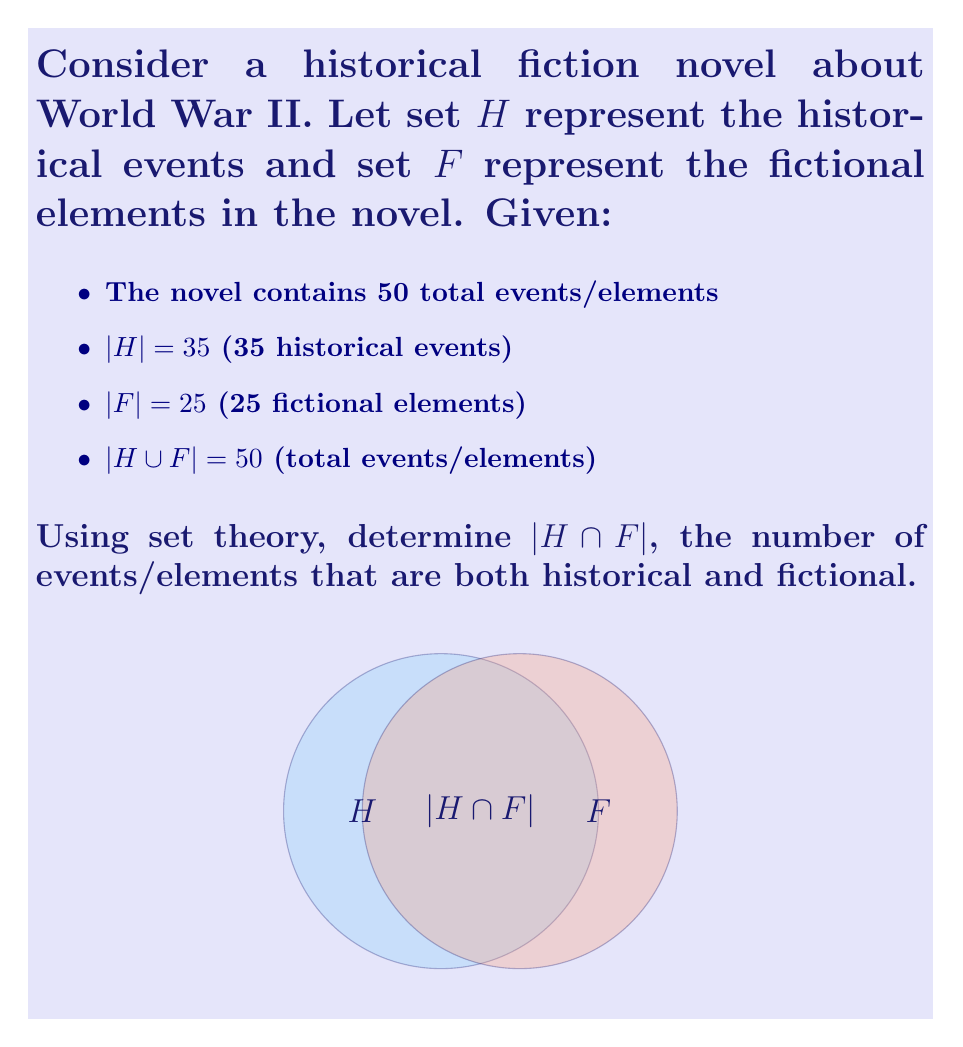Help me with this question. Let's approach this step-by-step using set theory:

1) We know that for two sets A and B:
   $|A \cup B| = |A| + |B| - |A \cap B|$

2) In our case:
   $|H \cup F| = |H| + |F| - |H \cap F|$

3) Substituting the known values:
   $50 = 35 + 25 - |H \cap F|$

4) Simplifying:
   $50 = 60 - |H \cap F|$

5) Subtracting 60 from both sides:
   $-10 = -|H \cap F|$

6) Multiplying both sides by -1:
   $10 = |H \cap F|$

Therefore, there are 10 events/elements that are both historical and fictional in the novel.

This intersection represents elements that have a basis in historical fact but have been fictionalized or embellished by the author, blending reality with imagination to create a more engaging narrative.
Answer: $|H \cap F| = 10$ 